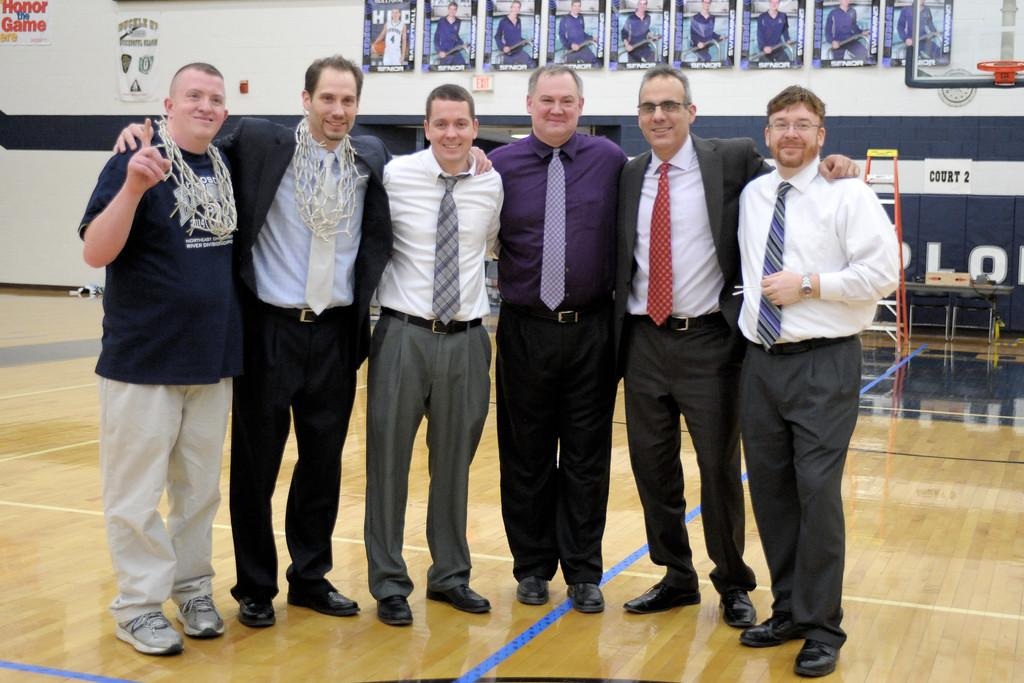How many men are present in the image? There are six men in the image. What are the men doing in the image? The men are standing on the ground and smiling. What can be seen in the background of the image? There are posters on the wall, a ladder, and some unspecified objects in the background. What is the rate of the father's observation in the image? There is no father present in the image, and therefore no observation rate can be determined. 